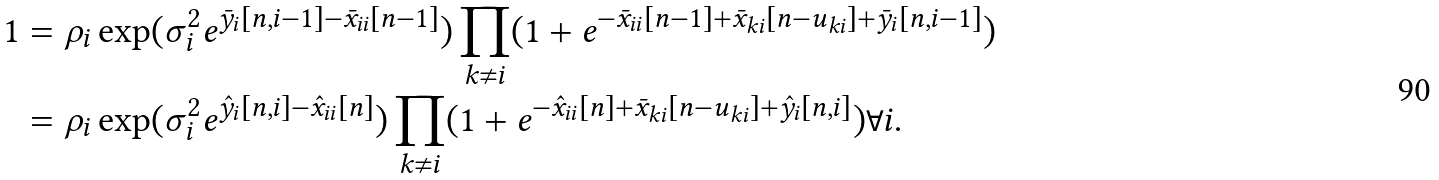Convert formula to latex. <formula><loc_0><loc_0><loc_500><loc_500>1 & = \rho _ { i } \exp ( \sigma _ { i } ^ { 2 } e ^ { \bar { y } _ { i } [ n , i - 1 ] - \bar { x } _ { i i } [ n - 1 ] } ) \prod _ { k \ne { i } } ( 1 + e ^ { - \bar { x } _ { i i } [ n - 1 ] + \bar { x } _ { k i } [ n - u _ { k i } ] + \bar { y } _ { i } [ n , i - 1 ] } ) \\ & = \rho _ { i } \exp ( \sigma _ { i } ^ { 2 } e ^ { \hat { y } _ { i } [ n , i ] - \hat { x } _ { i i } [ n ] } ) \prod _ { k \ne { i } } ( 1 + e ^ { - \hat { x } _ { i i } [ n ] + \bar { x } _ { k i } [ n - u _ { k i } ] + \hat { y } _ { i } [ n , i ] } ) \forall { i } .</formula> 